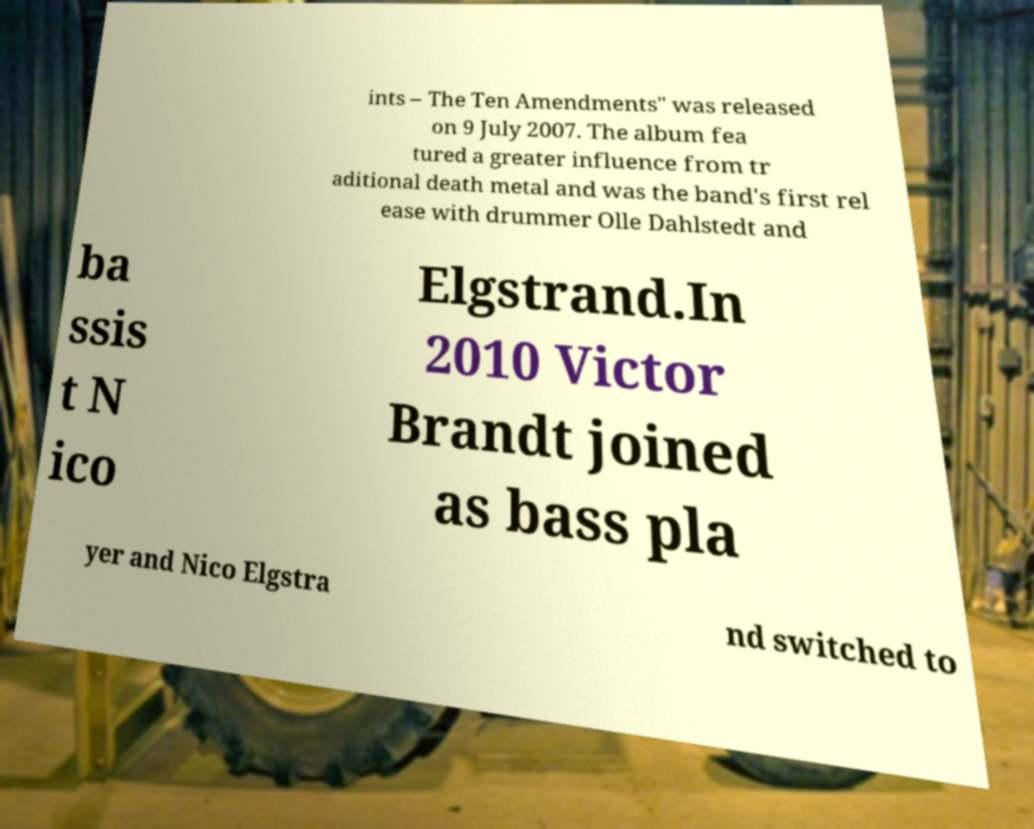I need the written content from this picture converted into text. Can you do that? ints – The Ten Amendments" was released on 9 July 2007. The album fea tured a greater influence from tr aditional death metal and was the band's first rel ease with drummer Olle Dahlstedt and ba ssis t N ico Elgstrand.In 2010 Victor Brandt joined as bass pla yer and Nico Elgstra nd switched to 